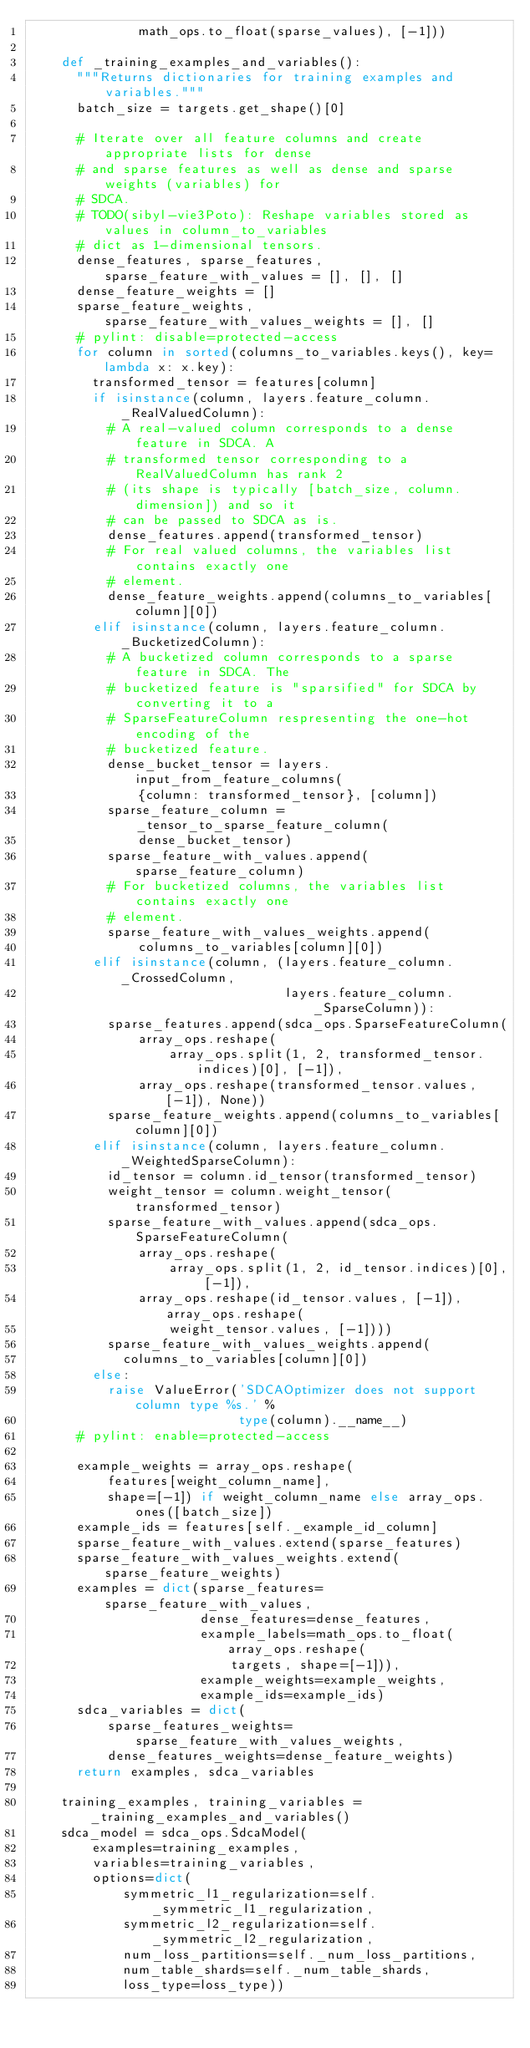Convert code to text. <code><loc_0><loc_0><loc_500><loc_500><_Python_>              math_ops.to_float(sparse_values), [-1]))

    def _training_examples_and_variables():
      """Returns dictionaries for training examples and variables."""
      batch_size = targets.get_shape()[0]

      # Iterate over all feature columns and create appropriate lists for dense
      # and sparse features as well as dense and sparse weights (variables) for
      # SDCA.
      # TODO(sibyl-vie3Poto): Reshape variables stored as values in column_to_variables
      # dict as 1-dimensional tensors.
      dense_features, sparse_features, sparse_feature_with_values = [], [], []
      dense_feature_weights = []
      sparse_feature_weights, sparse_feature_with_values_weights = [], []
      # pylint: disable=protected-access
      for column in sorted(columns_to_variables.keys(), key=lambda x: x.key):
        transformed_tensor = features[column]
        if isinstance(column, layers.feature_column._RealValuedColumn):
          # A real-valued column corresponds to a dense feature in SDCA. A
          # transformed tensor corresponding to a RealValuedColumn has rank 2
          # (its shape is typically [batch_size, column.dimension]) and so it
          # can be passed to SDCA as is.
          dense_features.append(transformed_tensor)
          # For real valued columns, the variables list contains exactly one
          # element.
          dense_feature_weights.append(columns_to_variables[column][0])
        elif isinstance(column, layers.feature_column._BucketizedColumn):
          # A bucketized column corresponds to a sparse feature in SDCA. The
          # bucketized feature is "sparsified" for SDCA by converting it to a
          # SparseFeatureColumn respresenting the one-hot encoding of the
          # bucketized feature.
          dense_bucket_tensor = layers.input_from_feature_columns(
              {column: transformed_tensor}, [column])
          sparse_feature_column = _tensor_to_sparse_feature_column(
              dense_bucket_tensor)
          sparse_feature_with_values.append(sparse_feature_column)
          # For bucketized columns, the variables list contains exactly one
          # element.
          sparse_feature_with_values_weights.append(
              columns_to_variables[column][0])
        elif isinstance(column, (layers.feature_column._CrossedColumn,
                                 layers.feature_column._SparseColumn)):
          sparse_features.append(sdca_ops.SparseFeatureColumn(
              array_ops.reshape(
                  array_ops.split(1, 2, transformed_tensor.indices)[0], [-1]),
              array_ops.reshape(transformed_tensor.values, [-1]), None))
          sparse_feature_weights.append(columns_to_variables[column][0])
        elif isinstance(column, layers.feature_column._WeightedSparseColumn):
          id_tensor = column.id_tensor(transformed_tensor)
          weight_tensor = column.weight_tensor(transformed_tensor)
          sparse_feature_with_values.append(sdca_ops.SparseFeatureColumn(
              array_ops.reshape(
                  array_ops.split(1, 2, id_tensor.indices)[0], [-1]),
              array_ops.reshape(id_tensor.values, [-1]), array_ops.reshape(
                  weight_tensor.values, [-1])))
          sparse_feature_with_values_weights.append(
            columns_to_variables[column][0])
        else:
          raise ValueError('SDCAOptimizer does not support column type %s.' %
                           type(column).__name__)
      # pylint: enable=protected-access

      example_weights = array_ops.reshape(
          features[weight_column_name],
          shape=[-1]) if weight_column_name else array_ops.ones([batch_size])
      example_ids = features[self._example_id_column]
      sparse_feature_with_values.extend(sparse_features)
      sparse_feature_with_values_weights.extend(sparse_feature_weights)
      examples = dict(sparse_features=sparse_feature_with_values,
                      dense_features=dense_features,
                      example_labels=math_ops.to_float(array_ops.reshape(
                          targets, shape=[-1])),
                      example_weights=example_weights,
                      example_ids=example_ids)
      sdca_variables = dict(
          sparse_features_weights=sparse_feature_with_values_weights,
          dense_features_weights=dense_feature_weights)
      return examples, sdca_variables

    training_examples, training_variables = _training_examples_and_variables()
    sdca_model = sdca_ops.SdcaModel(
        examples=training_examples,
        variables=training_variables,
        options=dict(
            symmetric_l1_regularization=self._symmetric_l1_regularization,
            symmetric_l2_regularization=self._symmetric_l2_regularization,
            num_loss_partitions=self._num_loss_partitions,
            num_table_shards=self._num_table_shards,
            loss_type=loss_type))</code> 